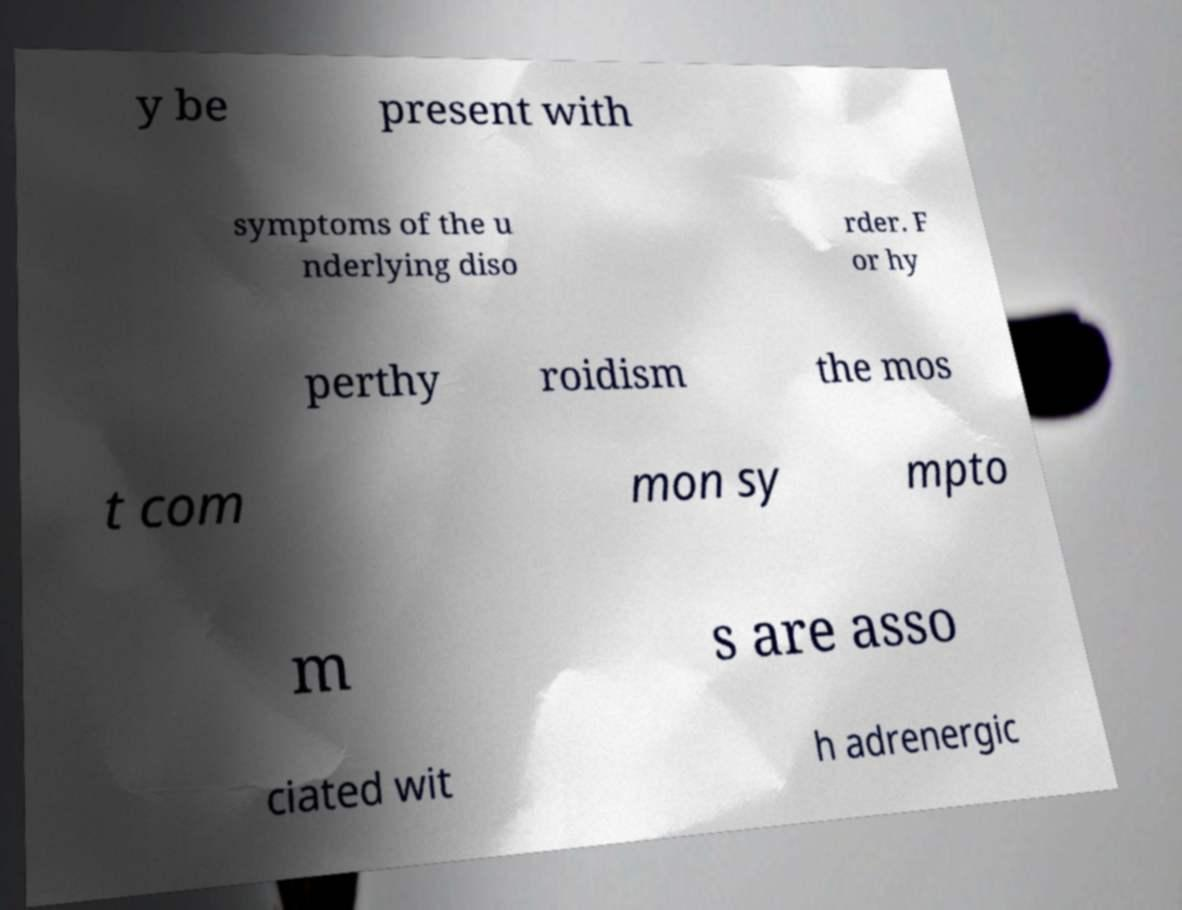There's text embedded in this image that I need extracted. Can you transcribe it verbatim? y be present with symptoms of the u nderlying diso rder. F or hy perthy roidism the mos t com mon sy mpto m s are asso ciated wit h adrenergic 